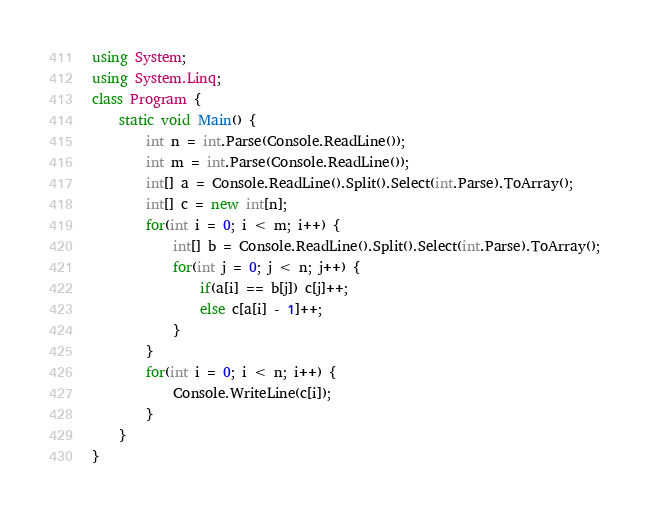Convert code to text. <code><loc_0><loc_0><loc_500><loc_500><_C#_>using System;
using System.Linq;
class Program {
	static void Main() {
		int n = int.Parse(Console.ReadLine());
		int m = int.Parse(Console.ReadLine());
		int[] a = Console.ReadLine().Split().Select(int.Parse).ToArray();
		int[] c = new int[n];
		for(int i = 0; i < m; i++) {
			int[] b = Console.ReadLine().Split().Select(int.Parse).ToArray();
			for(int j = 0; j < n; j++) {
				if(a[i] == b[j]) c[j]++;
				else c[a[i] - 1]++;
			}
		}
		for(int i = 0; i < n; i++) {
			Console.WriteLine(c[i]);
		}
	}
}</code> 